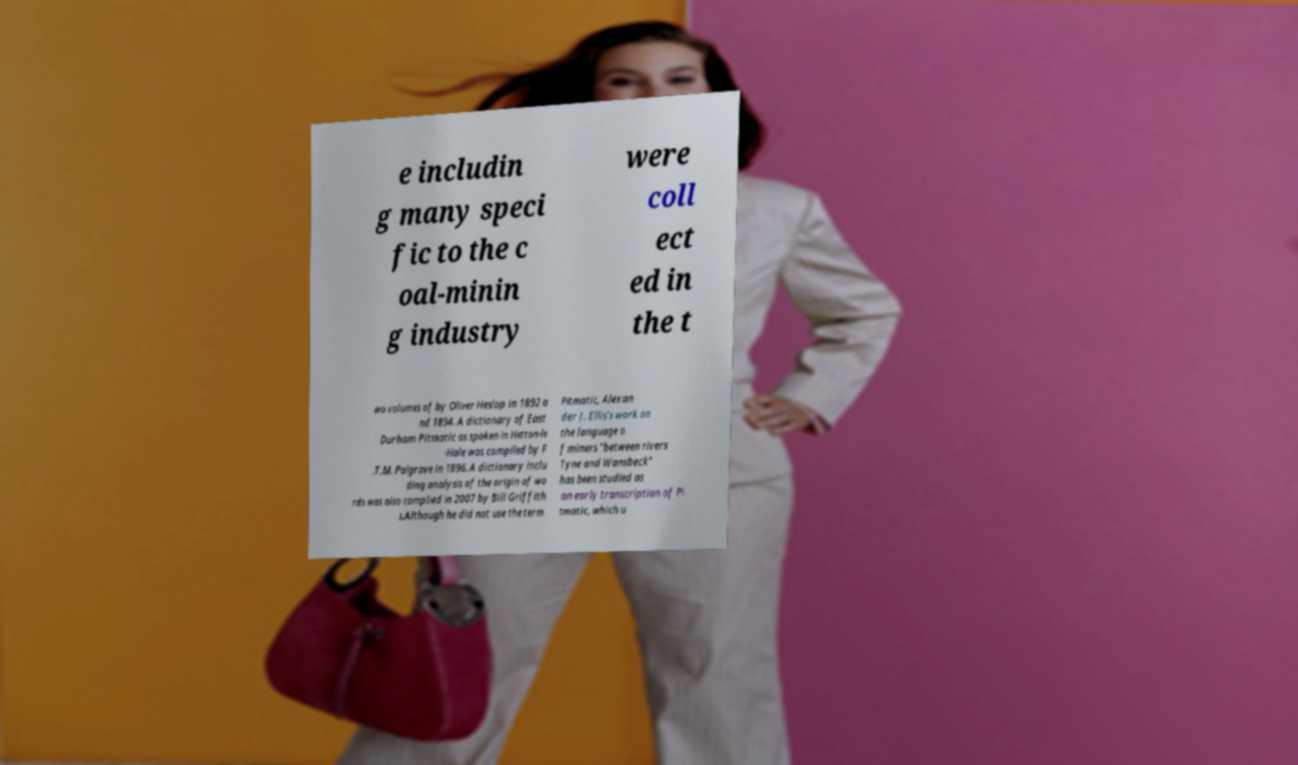Could you assist in decoding the text presented in this image and type it out clearly? e includin g many speci fic to the c oal-minin g industry were coll ect ed in the t wo volumes of by Oliver Heslop in 1892 a nd 1894. A dictionary of East Durham Pitmatic as spoken in Hetton-le -Hole was compiled by F .T.M. Palgrave in 1896. A dictionary inclu ding analysis of the origin of wo rds was also complied in 2007 by Bill Griffith s.Although he did not use the term Pitmatic, Alexan der J. Ellis's work on the language o f miners "between rivers Tyne and Wansbeck" has been studied as an early transcription of Pi tmatic, which u 